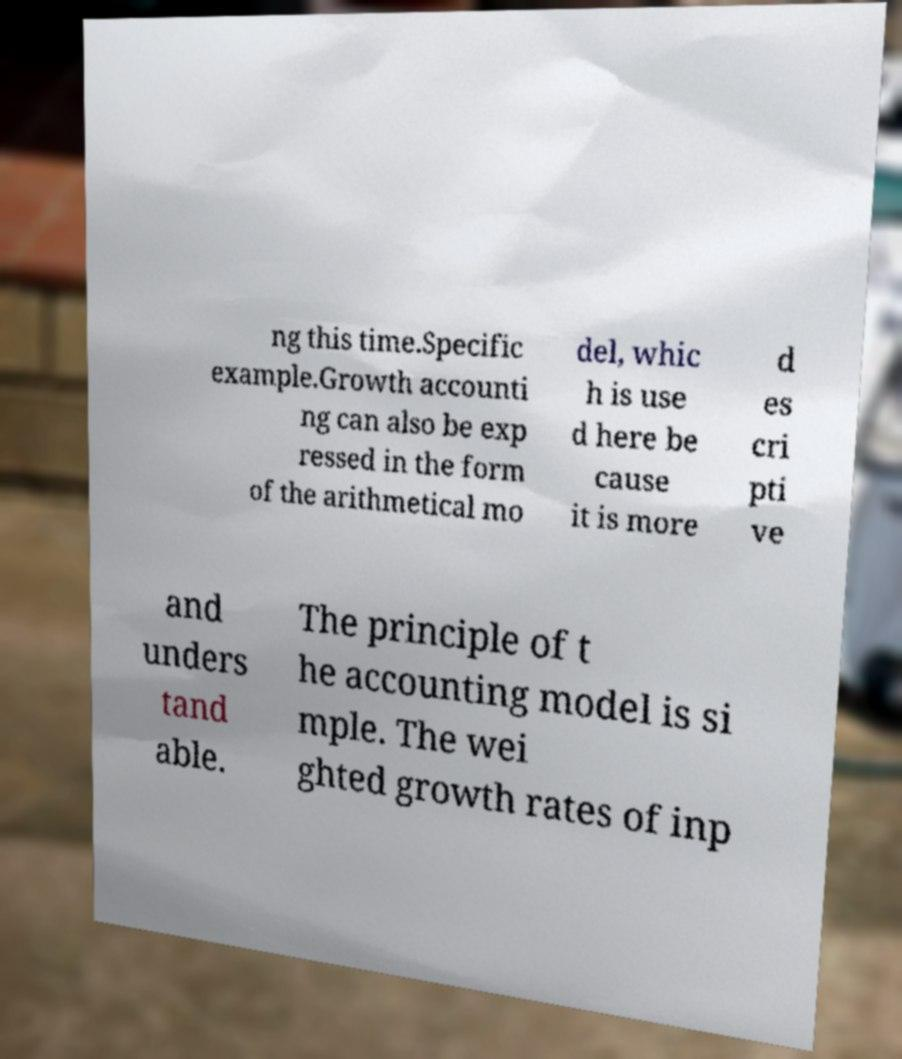What messages or text are displayed in this image? I need them in a readable, typed format. ng this time.Specific example.Growth accounti ng can also be exp ressed in the form of the arithmetical mo del, whic h is use d here be cause it is more d es cri pti ve and unders tand able. The principle of t he accounting model is si mple. The wei ghted growth rates of inp 